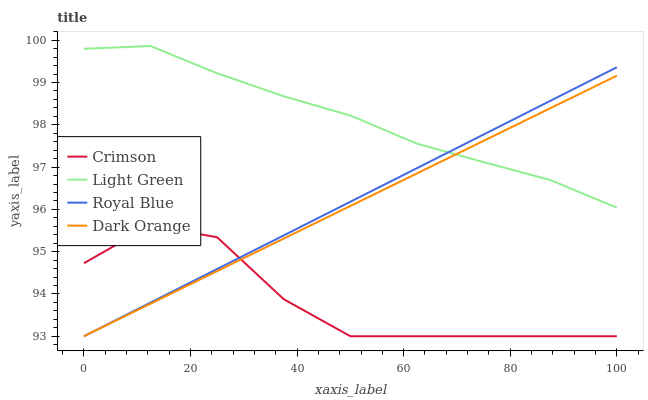Does Crimson have the minimum area under the curve?
Answer yes or no. Yes. Does Light Green have the maximum area under the curve?
Answer yes or no. Yes. Does Royal Blue have the minimum area under the curve?
Answer yes or no. No. Does Royal Blue have the maximum area under the curve?
Answer yes or no. No. Is Royal Blue the smoothest?
Answer yes or no. Yes. Is Crimson the roughest?
Answer yes or no. Yes. Is Light Green the smoothest?
Answer yes or no. No. Is Light Green the roughest?
Answer yes or no. No. Does Crimson have the lowest value?
Answer yes or no. Yes. Does Light Green have the lowest value?
Answer yes or no. No. Does Light Green have the highest value?
Answer yes or no. Yes. Does Royal Blue have the highest value?
Answer yes or no. No. Is Crimson less than Light Green?
Answer yes or no. Yes. Is Light Green greater than Crimson?
Answer yes or no. Yes. Does Dark Orange intersect Royal Blue?
Answer yes or no. Yes. Is Dark Orange less than Royal Blue?
Answer yes or no. No. Is Dark Orange greater than Royal Blue?
Answer yes or no. No. Does Crimson intersect Light Green?
Answer yes or no. No. 